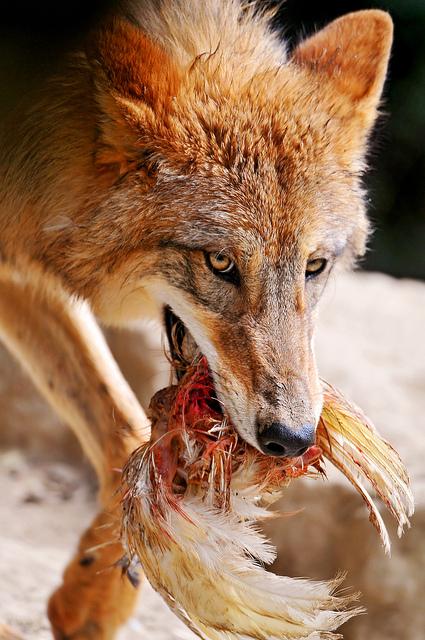Is the wolf eating another animal?
Quick response, please. Yes. Is the bird alive?
Quick response, please. No. What color is the wolf?
Give a very brief answer. Brown. 